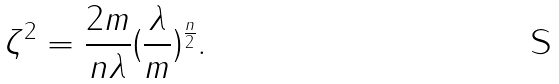Convert formula to latex. <formula><loc_0><loc_0><loc_500><loc_500>\zeta ^ { 2 } = \frac { 2 m } { n \lambda } ( \frac { \lambda } { m } ) ^ { \frac { n } { 2 } } .</formula> 